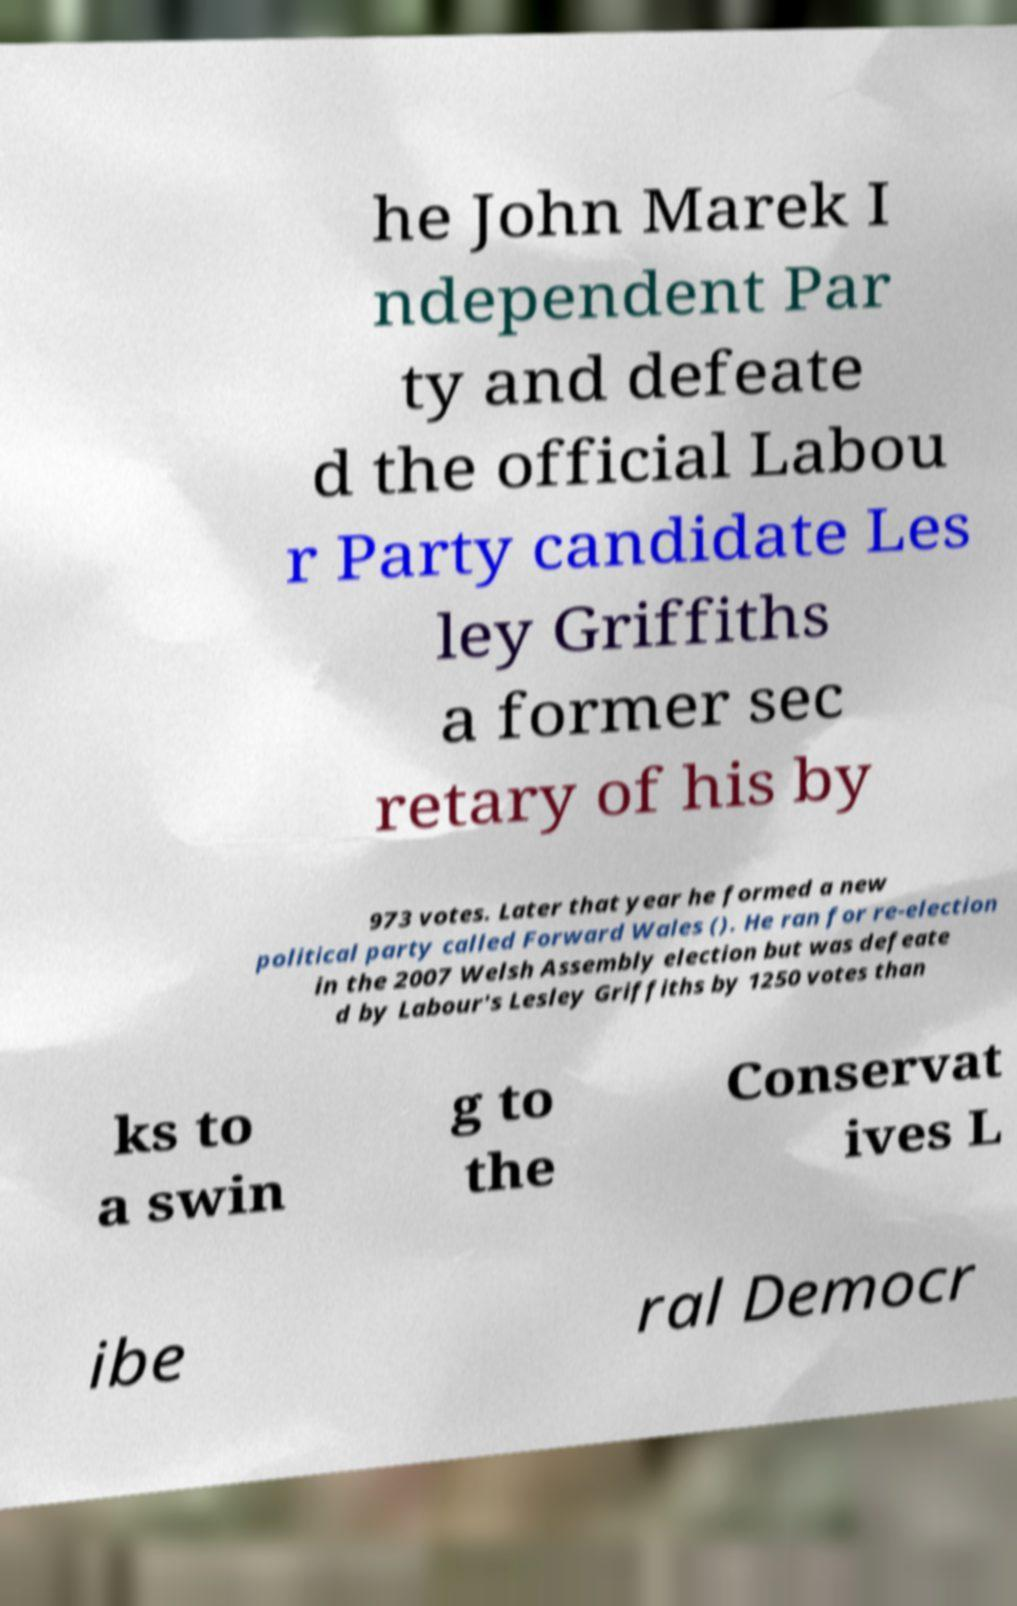What messages or text are displayed in this image? I need them in a readable, typed format. he John Marek I ndependent Par ty and defeate d the official Labou r Party candidate Les ley Griffiths a former sec retary of his by 973 votes. Later that year he formed a new political party called Forward Wales (). He ran for re-election in the 2007 Welsh Assembly election but was defeate d by Labour's Lesley Griffiths by 1250 votes than ks to a swin g to the Conservat ives L ibe ral Democr 